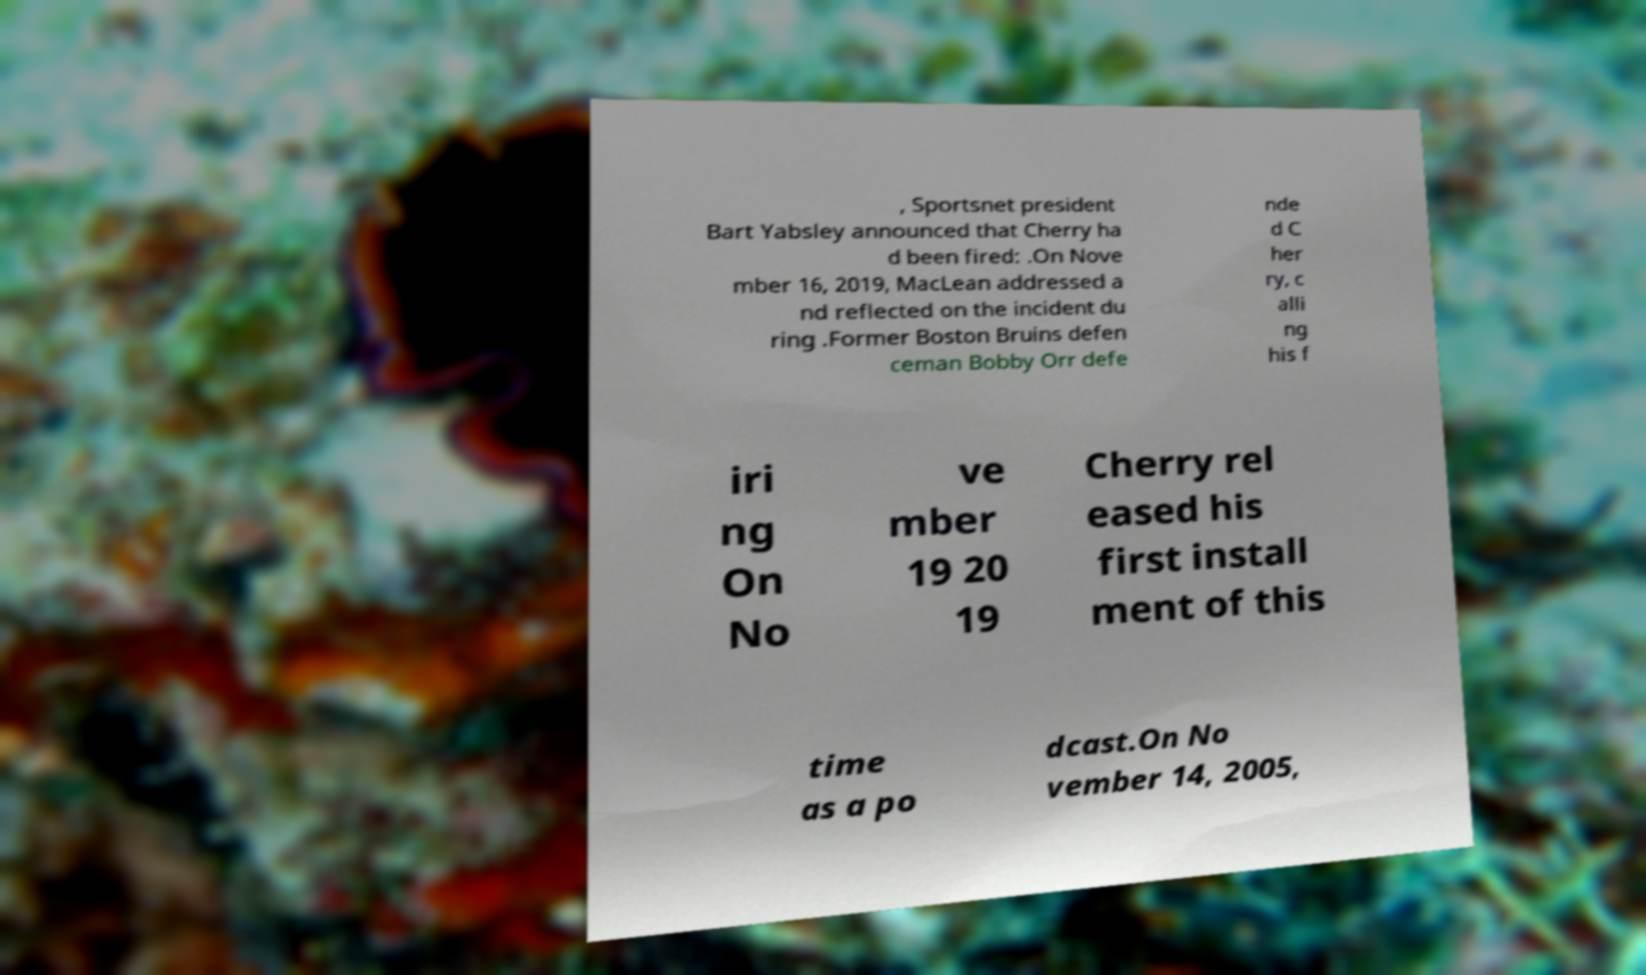There's text embedded in this image that I need extracted. Can you transcribe it verbatim? , Sportsnet president Bart Yabsley announced that Cherry ha d been fired: .On Nove mber 16, 2019, MacLean addressed a nd reflected on the incident du ring .Former Boston Bruins defen ceman Bobby Orr defe nde d C her ry, c alli ng his f iri ng On No ve mber 19 20 19 Cherry rel eased his first install ment of this time as a po dcast.On No vember 14, 2005, 